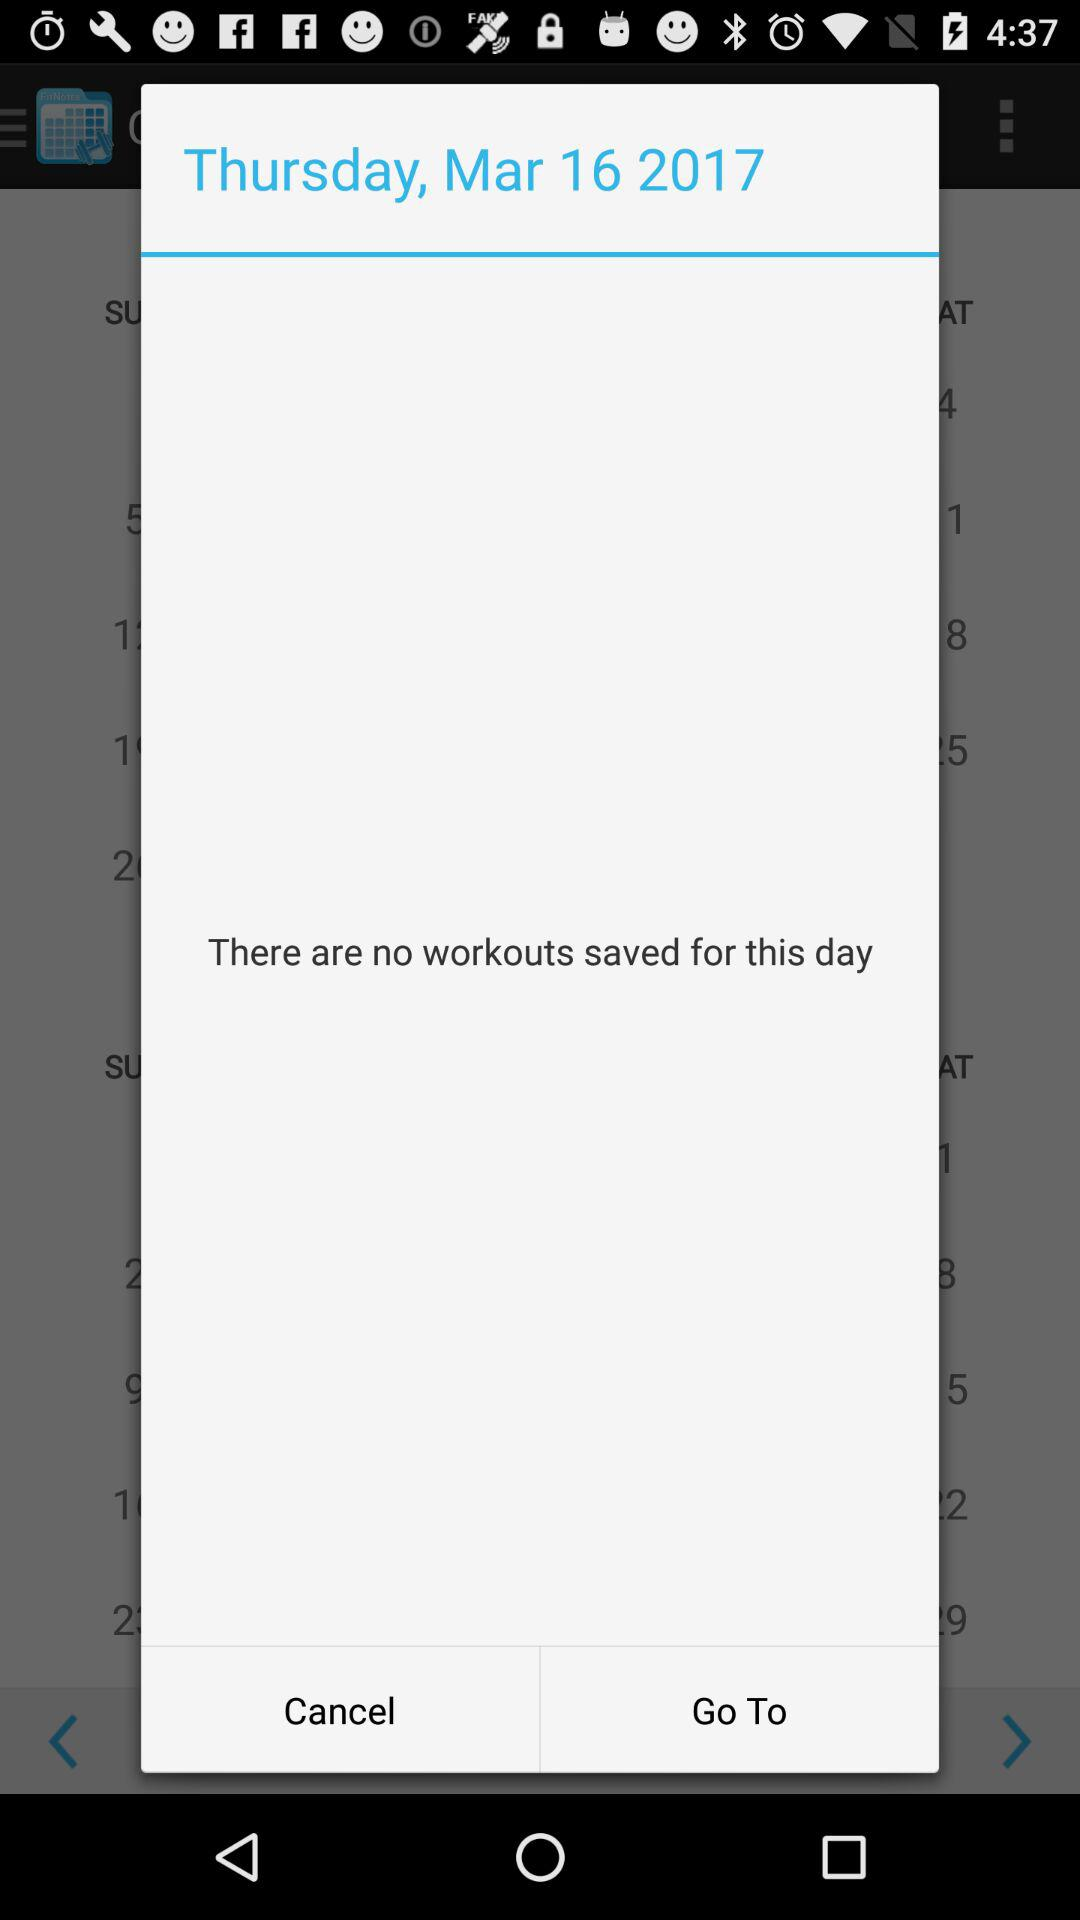Which date is displayed on the screen? The date is Thursday, March 16, 2017. 